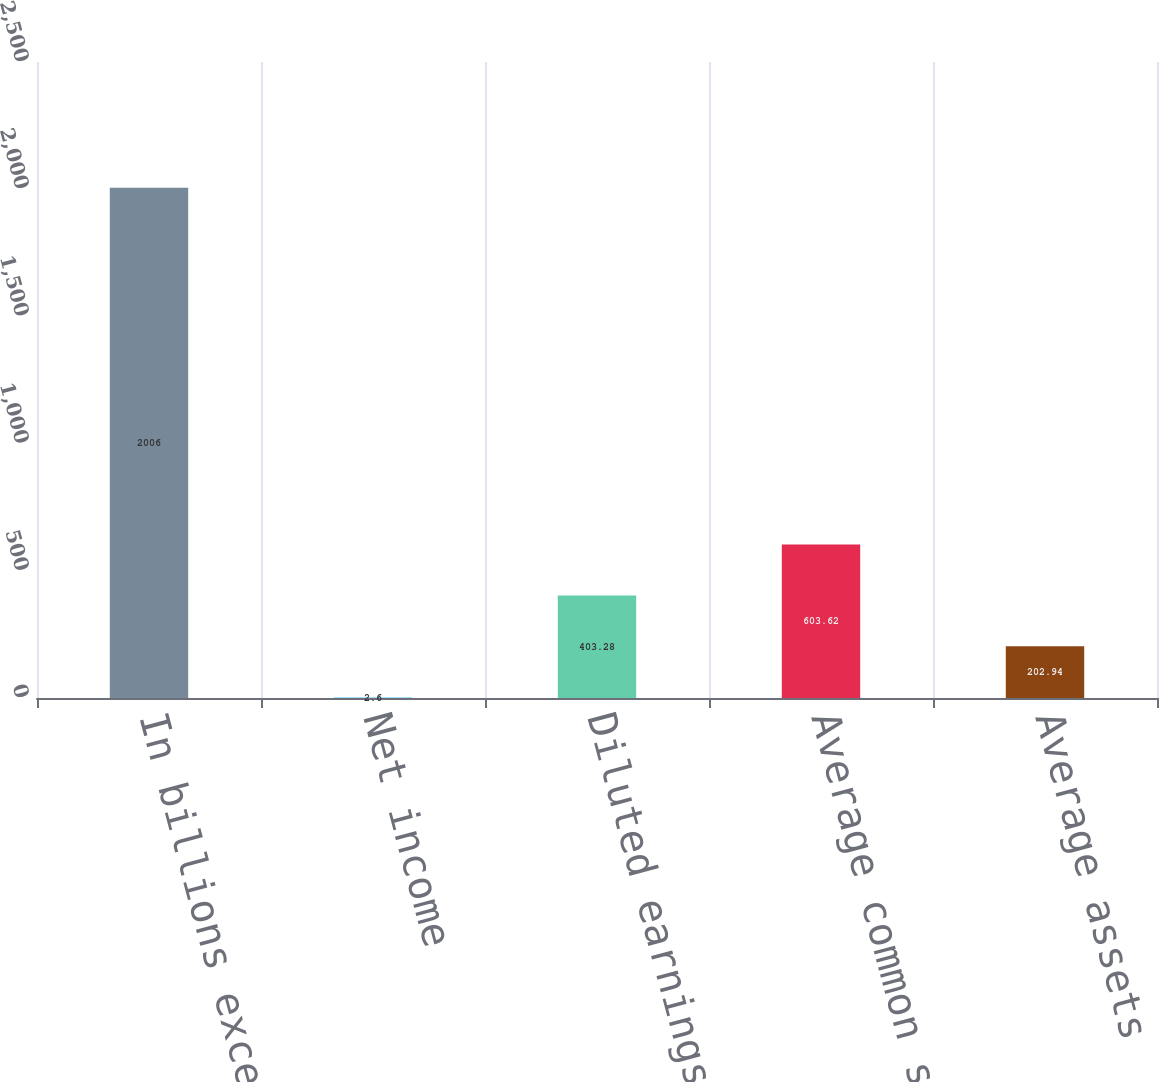<chart> <loc_0><loc_0><loc_500><loc_500><bar_chart><fcel>In billions except for per<fcel>Net income<fcel>Diluted earnings per share<fcel>Average common shareholders'<fcel>Average assets<nl><fcel>2006<fcel>2.6<fcel>403.28<fcel>603.62<fcel>202.94<nl></chart> 